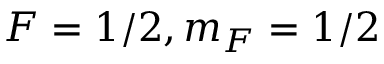Convert formula to latex. <formula><loc_0><loc_0><loc_500><loc_500>F = 1 / 2 , m _ { F } = 1 / 2</formula> 